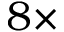<formula> <loc_0><loc_0><loc_500><loc_500>8 \times</formula> 